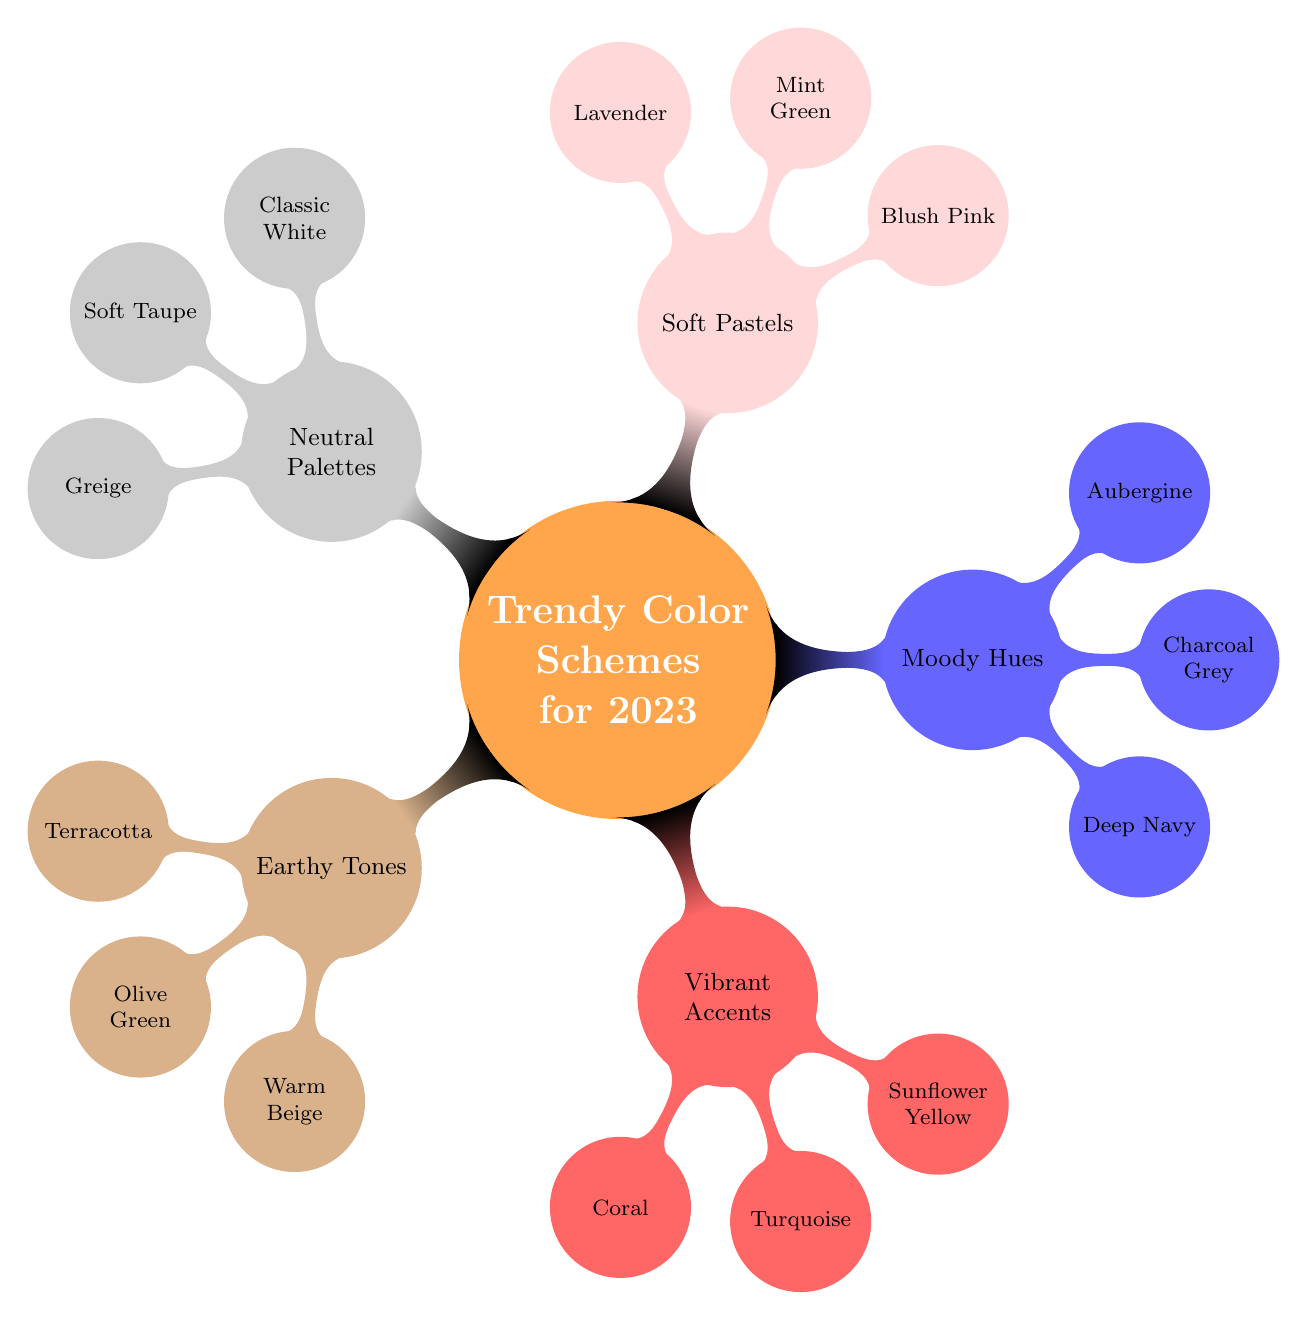What are the key shades of Earthy Tones? The Earthy Tones node indicates three key shades: Terracotta, Olive Green, and Warm Beige.
Answer: Terracotta, Olive Green, Warm Beige How many applications are listed for Vibrant Accents? The Vibrant Accents node mentions three applications: Accent Walls, Furniture, and Accessories, leading to a total of three applications.
Answer: 3 What color scheme includes deep navy? The diagram shows that Deep Navy is part of the Moody Hues color scheme.
Answer: Moody Hues Which color is associated with Soft Pastels? The Soft Pastels node contains three key shades: Blush Pink, Mint Green, and Lavender, one of which is Blush Pink.
Answer: Blush Pink What is the relationship between Neutral Palettes and its key shades? The Neutral Palettes node includes three key shades: Classic White, Soft Taupe, and Greige, indicating they are all part of the Neutral Palettes scheme.
Answer: Classic White, Soft Taupe, Greige How many key shades does the Moody Hues scheme have? The Moody Hues node specifies three key shades: Deep Navy, Charcoal Grey, and Aubergine, resulting in a total of three key shades.
Answer: 3 Which color scheme has applications in nurseries? The Soft Pastels node lists Nurseries among its applications, indicating it is used specifically in that context.
Answer: Soft Pastels What is the main focus of the Mind Map? The main focus of the Mind Map is "Trendy Color Schemes for 2023," which encapsulates all the other nodes.
Answer: Trendy Color Schemes for 2023 Which color scheme is represented in warm tones? The Earthy Tones node reflects warm tones with shades like Terracotta and Warm Beige.
Answer: Earthy Tones 